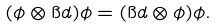<formula> <loc_0><loc_0><loc_500><loc_500>( \phi \otimes \i d ) \phi = ( \i d \otimes \phi ) \phi .</formula> 